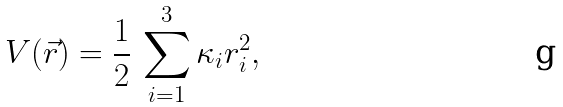Convert formula to latex. <formula><loc_0><loc_0><loc_500><loc_500>V ( \vec { r } ) = \frac { 1 } { 2 } \, \sum _ { i = 1 } ^ { 3 } \kappa _ { i } r _ { i } ^ { 2 } ,</formula> 